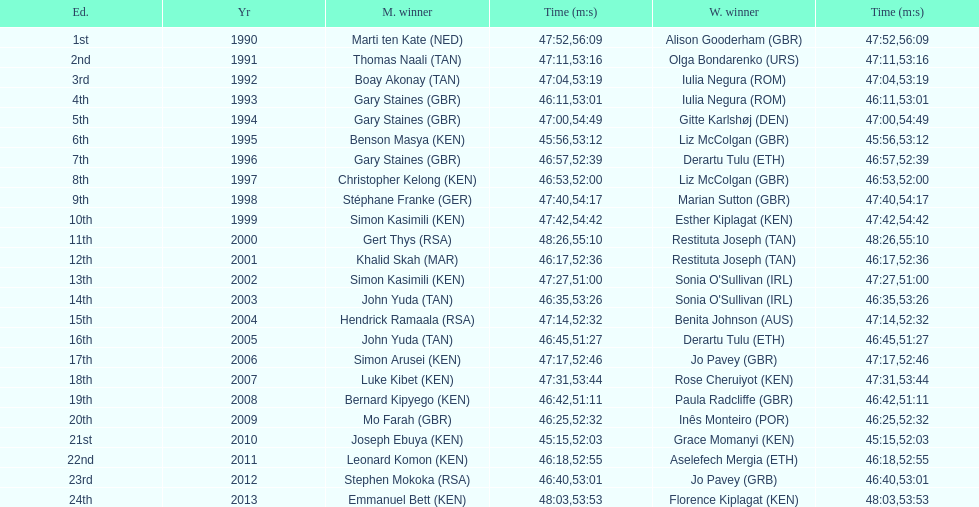The additional female champion with an identical completion time as jo pavey in 201 Iulia Negura. Would you mind parsing the complete table? {'header': ['Ed.', 'Yr', 'M. winner', 'Time (m:s)', 'W. winner', 'Time (m:s)'], 'rows': [['1st', '1990', 'Marti ten Kate\xa0(NED)', '47:52', 'Alison Gooderham\xa0(GBR)', '56:09'], ['2nd', '1991', 'Thomas Naali\xa0(TAN)', '47:11', 'Olga Bondarenko\xa0(URS)', '53:16'], ['3rd', '1992', 'Boay Akonay\xa0(TAN)', '47:04', 'Iulia Negura\xa0(ROM)', '53:19'], ['4th', '1993', 'Gary Staines\xa0(GBR)', '46:11', 'Iulia Negura\xa0(ROM)', '53:01'], ['5th', '1994', 'Gary Staines\xa0(GBR)', '47:00', 'Gitte Karlshøj\xa0(DEN)', '54:49'], ['6th', '1995', 'Benson Masya\xa0(KEN)', '45:56', 'Liz McColgan\xa0(GBR)', '53:12'], ['7th', '1996', 'Gary Staines\xa0(GBR)', '46:57', 'Derartu Tulu\xa0(ETH)', '52:39'], ['8th', '1997', 'Christopher Kelong\xa0(KEN)', '46:53', 'Liz McColgan\xa0(GBR)', '52:00'], ['9th', '1998', 'Stéphane Franke\xa0(GER)', '47:40', 'Marian Sutton\xa0(GBR)', '54:17'], ['10th', '1999', 'Simon Kasimili\xa0(KEN)', '47:42', 'Esther Kiplagat\xa0(KEN)', '54:42'], ['11th', '2000', 'Gert Thys\xa0(RSA)', '48:26', 'Restituta Joseph\xa0(TAN)', '55:10'], ['12th', '2001', 'Khalid Skah\xa0(MAR)', '46:17', 'Restituta Joseph\xa0(TAN)', '52:36'], ['13th', '2002', 'Simon Kasimili\xa0(KEN)', '47:27', "Sonia O'Sullivan\xa0(IRL)", '51:00'], ['14th', '2003', 'John Yuda\xa0(TAN)', '46:35', "Sonia O'Sullivan\xa0(IRL)", '53:26'], ['15th', '2004', 'Hendrick Ramaala\xa0(RSA)', '47:14', 'Benita Johnson\xa0(AUS)', '52:32'], ['16th', '2005', 'John Yuda\xa0(TAN)', '46:45', 'Derartu Tulu\xa0(ETH)', '51:27'], ['17th', '2006', 'Simon Arusei\xa0(KEN)', '47:17', 'Jo Pavey\xa0(GBR)', '52:46'], ['18th', '2007', 'Luke Kibet\xa0(KEN)', '47:31', 'Rose Cheruiyot\xa0(KEN)', '53:44'], ['19th', '2008', 'Bernard Kipyego\xa0(KEN)', '46:42', 'Paula Radcliffe\xa0(GBR)', '51:11'], ['20th', '2009', 'Mo Farah\xa0(GBR)', '46:25', 'Inês Monteiro\xa0(POR)', '52:32'], ['21st', '2010', 'Joseph Ebuya\xa0(KEN)', '45:15', 'Grace Momanyi\xa0(KEN)', '52:03'], ['22nd', '2011', 'Leonard Komon\xa0(KEN)', '46:18', 'Aselefech Mergia\xa0(ETH)', '52:55'], ['23rd', '2012', 'Stephen Mokoka\xa0(RSA)', '46:40', 'Jo Pavey\xa0(GRB)', '53:01'], ['24th', '2013', 'Emmanuel Bett\xa0(KEN)', '48:03', 'Florence Kiplagat\xa0(KEN)', '53:53']]} 